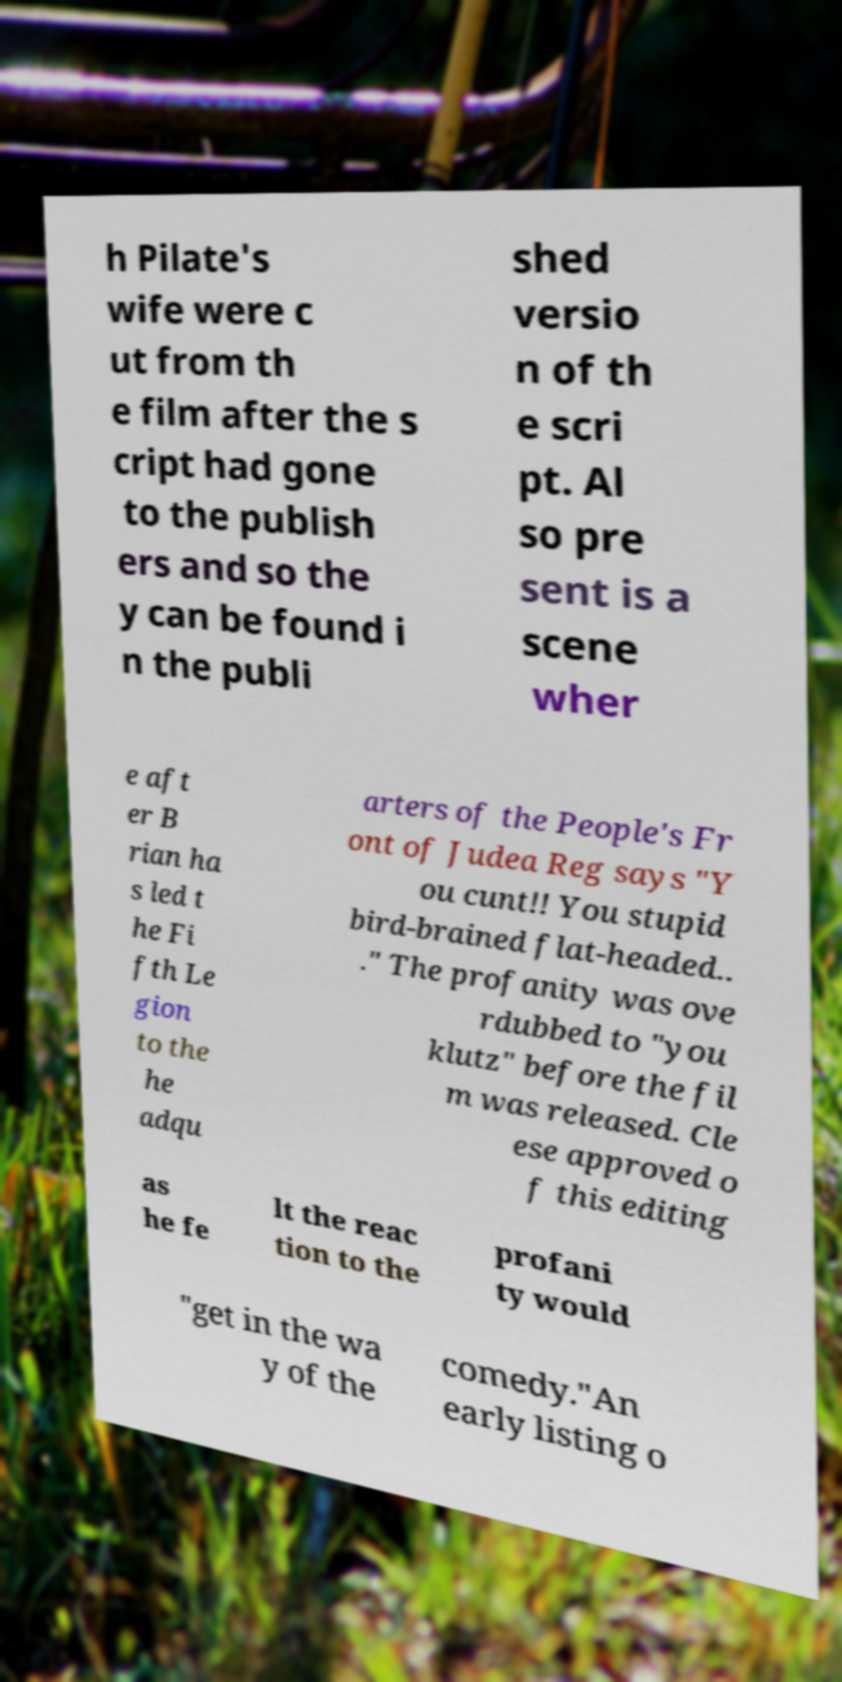Please identify and transcribe the text found in this image. h Pilate's wife were c ut from th e film after the s cript had gone to the publish ers and so the y can be found i n the publi shed versio n of th e scri pt. Al so pre sent is a scene wher e aft er B rian ha s led t he Fi fth Le gion to the he adqu arters of the People's Fr ont of Judea Reg says "Y ou cunt!! You stupid bird-brained flat-headed.. ." The profanity was ove rdubbed to "you klutz" before the fil m was released. Cle ese approved o f this editing as he fe lt the reac tion to the profani ty would "get in the wa y of the comedy."An early listing o 